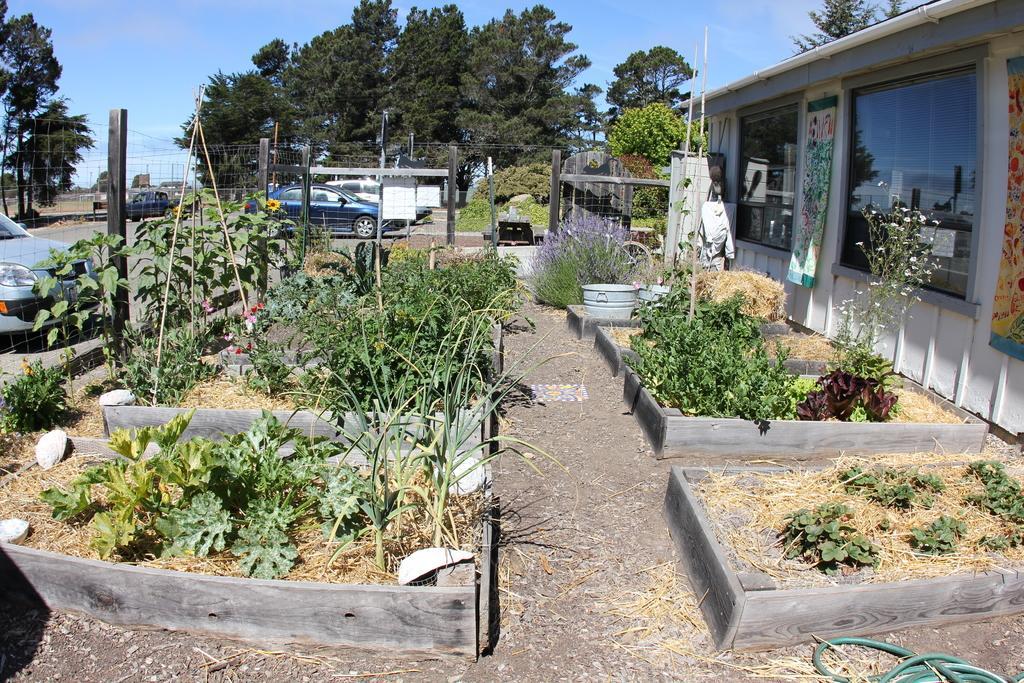Describe this image in one or two sentences. In this picture there is a building and there are trees and vehicles. In the foreground there are plants and there is a pipe and bucket. On the right side of the image there are objects on the wall. On the left side of the image there is a fence. At the back it looks like a building. At the top there is sky. At the bottom there is ground and there is grass. 